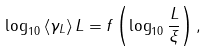Convert formula to latex. <formula><loc_0><loc_0><loc_500><loc_500>\log _ { 1 0 } \left < \gamma _ { L } \right > L = f \left ( \log _ { 1 0 } \frac { L } { \xi } \right ) ,</formula> 